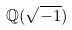Convert formula to latex. <formula><loc_0><loc_0><loc_500><loc_500>\mathbb { Q } ( \sqrt { - 1 } )</formula> 